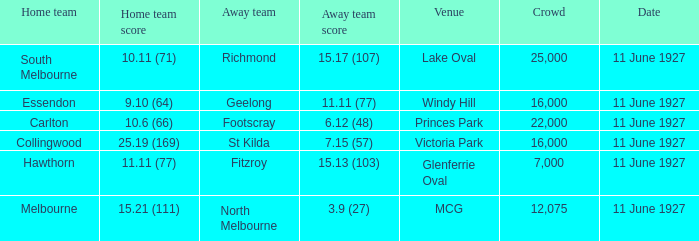How many people were in the crowd when Essendon was the home team? 1.0. 